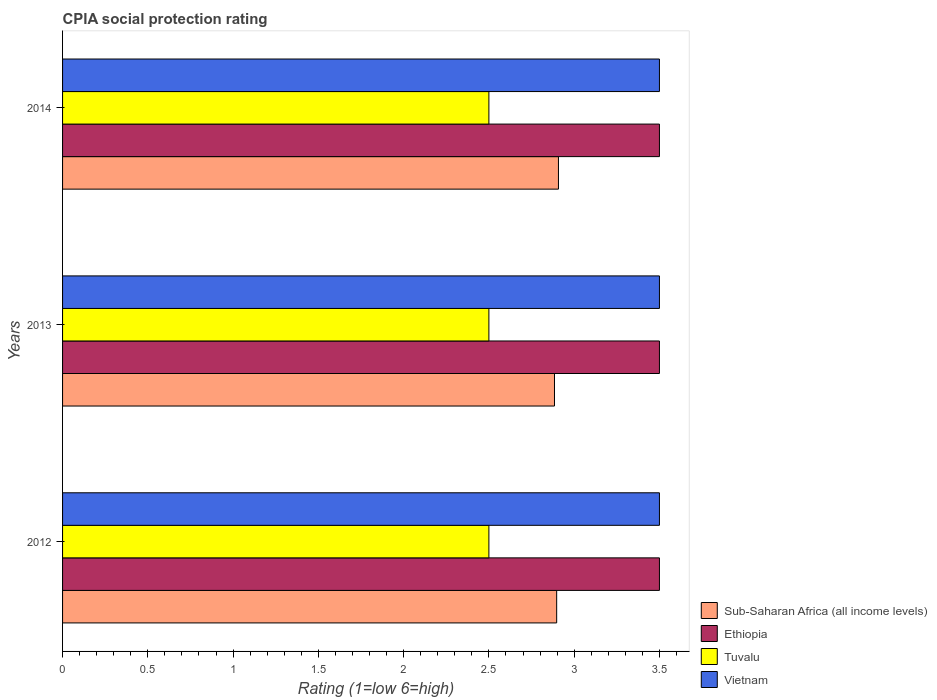How many different coloured bars are there?
Your answer should be compact. 4. How many groups of bars are there?
Offer a terse response. 3. Are the number of bars per tick equal to the number of legend labels?
Your response must be concise. Yes. In how many cases, is the number of bars for a given year not equal to the number of legend labels?
Keep it short and to the point. 0. What is the CPIA rating in Vietnam in 2013?
Give a very brief answer. 3.5. Across all years, what is the minimum CPIA rating in Sub-Saharan Africa (all income levels)?
Your answer should be very brief. 2.88. In which year was the CPIA rating in Tuvalu minimum?
Make the answer very short. 2012. What is the difference between the CPIA rating in Tuvalu in 2014 and the CPIA rating in Sub-Saharan Africa (all income levels) in 2013?
Provide a succinct answer. -0.38. What is the average CPIA rating in Sub-Saharan Africa (all income levels) per year?
Give a very brief answer. 2.9. In the year 2014, what is the difference between the CPIA rating in Vietnam and CPIA rating in Tuvalu?
Provide a short and direct response. 1. In how many years, is the CPIA rating in Sub-Saharan Africa (all income levels) greater than 0.6 ?
Ensure brevity in your answer.  3. What is the ratio of the CPIA rating in Ethiopia in 2013 to that in 2014?
Your answer should be compact. 1. Is the difference between the CPIA rating in Vietnam in 2012 and 2013 greater than the difference between the CPIA rating in Tuvalu in 2012 and 2013?
Make the answer very short. No. What does the 3rd bar from the top in 2014 represents?
Your response must be concise. Ethiopia. What does the 1st bar from the bottom in 2012 represents?
Your answer should be very brief. Sub-Saharan Africa (all income levels). Are all the bars in the graph horizontal?
Your response must be concise. Yes. How many years are there in the graph?
Offer a very short reply. 3. Does the graph contain grids?
Keep it short and to the point. No. Where does the legend appear in the graph?
Your response must be concise. Bottom right. How many legend labels are there?
Your answer should be very brief. 4. What is the title of the graph?
Keep it short and to the point. CPIA social protection rating. Does "Guatemala" appear as one of the legend labels in the graph?
Offer a terse response. No. What is the Rating (1=low 6=high) of Sub-Saharan Africa (all income levels) in 2012?
Your response must be concise. 2.9. What is the Rating (1=low 6=high) in Ethiopia in 2012?
Your answer should be compact. 3.5. What is the Rating (1=low 6=high) in Vietnam in 2012?
Make the answer very short. 3.5. What is the Rating (1=low 6=high) of Sub-Saharan Africa (all income levels) in 2013?
Your answer should be compact. 2.88. What is the Rating (1=low 6=high) of Ethiopia in 2013?
Provide a succinct answer. 3.5. What is the Rating (1=low 6=high) in Tuvalu in 2013?
Your answer should be compact. 2.5. What is the Rating (1=low 6=high) of Vietnam in 2013?
Provide a succinct answer. 3.5. What is the Rating (1=low 6=high) in Sub-Saharan Africa (all income levels) in 2014?
Make the answer very short. 2.91. What is the Rating (1=low 6=high) of Ethiopia in 2014?
Provide a short and direct response. 3.5. What is the Rating (1=low 6=high) of Tuvalu in 2014?
Provide a short and direct response. 2.5. Across all years, what is the maximum Rating (1=low 6=high) in Sub-Saharan Africa (all income levels)?
Your response must be concise. 2.91. Across all years, what is the maximum Rating (1=low 6=high) in Tuvalu?
Your answer should be very brief. 2.5. Across all years, what is the maximum Rating (1=low 6=high) in Vietnam?
Your answer should be compact. 3.5. Across all years, what is the minimum Rating (1=low 6=high) in Sub-Saharan Africa (all income levels)?
Your response must be concise. 2.88. Across all years, what is the minimum Rating (1=low 6=high) in Ethiopia?
Offer a very short reply. 3.5. Across all years, what is the minimum Rating (1=low 6=high) in Vietnam?
Your response must be concise. 3.5. What is the total Rating (1=low 6=high) of Sub-Saharan Africa (all income levels) in the graph?
Offer a terse response. 8.69. What is the total Rating (1=low 6=high) of Ethiopia in the graph?
Provide a succinct answer. 10.5. What is the difference between the Rating (1=low 6=high) of Sub-Saharan Africa (all income levels) in 2012 and that in 2013?
Provide a succinct answer. 0.01. What is the difference between the Rating (1=low 6=high) in Ethiopia in 2012 and that in 2013?
Offer a very short reply. 0. What is the difference between the Rating (1=low 6=high) in Sub-Saharan Africa (all income levels) in 2012 and that in 2014?
Provide a succinct answer. -0.01. What is the difference between the Rating (1=low 6=high) of Ethiopia in 2012 and that in 2014?
Offer a terse response. 0. What is the difference between the Rating (1=low 6=high) in Sub-Saharan Africa (all income levels) in 2013 and that in 2014?
Your response must be concise. -0.02. What is the difference between the Rating (1=low 6=high) of Ethiopia in 2013 and that in 2014?
Offer a terse response. 0. What is the difference between the Rating (1=low 6=high) in Sub-Saharan Africa (all income levels) in 2012 and the Rating (1=low 6=high) in Ethiopia in 2013?
Make the answer very short. -0.6. What is the difference between the Rating (1=low 6=high) of Sub-Saharan Africa (all income levels) in 2012 and the Rating (1=low 6=high) of Tuvalu in 2013?
Offer a terse response. 0.4. What is the difference between the Rating (1=low 6=high) in Sub-Saharan Africa (all income levels) in 2012 and the Rating (1=low 6=high) in Vietnam in 2013?
Offer a very short reply. -0.6. What is the difference between the Rating (1=low 6=high) of Sub-Saharan Africa (all income levels) in 2012 and the Rating (1=low 6=high) of Ethiopia in 2014?
Provide a short and direct response. -0.6. What is the difference between the Rating (1=low 6=high) of Sub-Saharan Africa (all income levels) in 2012 and the Rating (1=low 6=high) of Tuvalu in 2014?
Offer a terse response. 0.4. What is the difference between the Rating (1=low 6=high) in Sub-Saharan Africa (all income levels) in 2012 and the Rating (1=low 6=high) in Vietnam in 2014?
Your response must be concise. -0.6. What is the difference between the Rating (1=low 6=high) of Ethiopia in 2012 and the Rating (1=low 6=high) of Tuvalu in 2014?
Your answer should be compact. 1. What is the difference between the Rating (1=low 6=high) of Ethiopia in 2012 and the Rating (1=low 6=high) of Vietnam in 2014?
Offer a very short reply. 0. What is the difference between the Rating (1=low 6=high) of Sub-Saharan Africa (all income levels) in 2013 and the Rating (1=low 6=high) of Ethiopia in 2014?
Offer a very short reply. -0.62. What is the difference between the Rating (1=low 6=high) of Sub-Saharan Africa (all income levels) in 2013 and the Rating (1=low 6=high) of Tuvalu in 2014?
Provide a succinct answer. 0.38. What is the difference between the Rating (1=low 6=high) in Sub-Saharan Africa (all income levels) in 2013 and the Rating (1=low 6=high) in Vietnam in 2014?
Your answer should be compact. -0.62. What is the difference between the Rating (1=low 6=high) in Ethiopia in 2013 and the Rating (1=low 6=high) in Vietnam in 2014?
Your response must be concise. 0. What is the average Rating (1=low 6=high) in Sub-Saharan Africa (all income levels) per year?
Your response must be concise. 2.9. What is the average Rating (1=low 6=high) of Ethiopia per year?
Ensure brevity in your answer.  3.5. In the year 2012, what is the difference between the Rating (1=low 6=high) of Sub-Saharan Africa (all income levels) and Rating (1=low 6=high) of Ethiopia?
Offer a very short reply. -0.6. In the year 2012, what is the difference between the Rating (1=low 6=high) of Sub-Saharan Africa (all income levels) and Rating (1=low 6=high) of Tuvalu?
Your response must be concise. 0.4. In the year 2012, what is the difference between the Rating (1=low 6=high) of Sub-Saharan Africa (all income levels) and Rating (1=low 6=high) of Vietnam?
Give a very brief answer. -0.6. In the year 2012, what is the difference between the Rating (1=low 6=high) in Ethiopia and Rating (1=low 6=high) in Tuvalu?
Your answer should be very brief. 1. In the year 2013, what is the difference between the Rating (1=low 6=high) in Sub-Saharan Africa (all income levels) and Rating (1=low 6=high) in Ethiopia?
Make the answer very short. -0.62. In the year 2013, what is the difference between the Rating (1=low 6=high) in Sub-Saharan Africa (all income levels) and Rating (1=low 6=high) in Tuvalu?
Offer a very short reply. 0.38. In the year 2013, what is the difference between the Rating (1=low 6=high) in Sub-Saharan Africa (all income levels) and Rating (1=low 6=high) in Vietnam?
Keep it short and to the point. -0.62. In the year 2013, what is the difference between the Rating (1=low 6=high) of Ethiopia and Rating (1=low 6=high) of Tuvalu?
Provide a short and direct response. 1. In the year 2014, what is the difference between the Rating (1=low 6=high) in Sub-Saharan Africa (all income levels) and Rating (1=low 6=high) in Ethiopia?
Give a very brief answer. -0.59. In the year 2014, what is the difference between the Rating (1=low 6=high) of Sub-Saharan Africa (all income levels) and Rating (1=low 6=high) of Tuvalu?
Provide a short and direct response. 0.41. In the year 2014, what is the difference between the Rating (1=low 6=high) of Sub-Saharan Africa (all income levels) and Rating (1=low 6=high) of Vietnam?
Provide a short and direct response. -0.59. In the year 2014, what is the difference between the Rating (1=low 6=high) in Tuvalu and Rating (1=low 6=high) in Vietnam?
Offer a very short reply. -1. What is the ratio of the Rating (1=low 6=high) of Sub-Saharan Africa (all income levels) in 2012 to that in 2013?
Offer a terse response. 1. What is the ratio of the Rating (1=low 6=high) of Tuvalu in 2012 to that in 2013?
Provide a short and direct response. 1. What is the ratio of the Rating (1=low 6=high) of Ethiopia in 2012 to that in 2014?
Keep it short and to the point. 1. What is the ratio of the Rating (1=low 6=high) in Sub-Saharan Africa (all income levels) in 2013 to that in 2014?
Provide a succinct answer. 0.99. What is the ratio of the Rating (1=low 6=high) in Tuvalu in 2013 to that in 2014?
Provide a short and direct response. 1. What is the ratio of the Rating (1=low 6=high) in Vietnam in 2013 to that in 2014?
Offer a very short reply. 1. What is the difference between the highest and the second highest Rating (1=low 6=high) of Sub-Saharan Africa (all income levels)?
Your response must be concise. 0.01. What is the difference between the highest and the second highest Rating (1=low 6=high) of Tuvalu?
Offer a terse response. 0. What is the difference between the highest and the lowest Rating (1=low 6=high) in Sub-Saharan Africa (all income levels)?
Your answer should be compact. 0.02. 